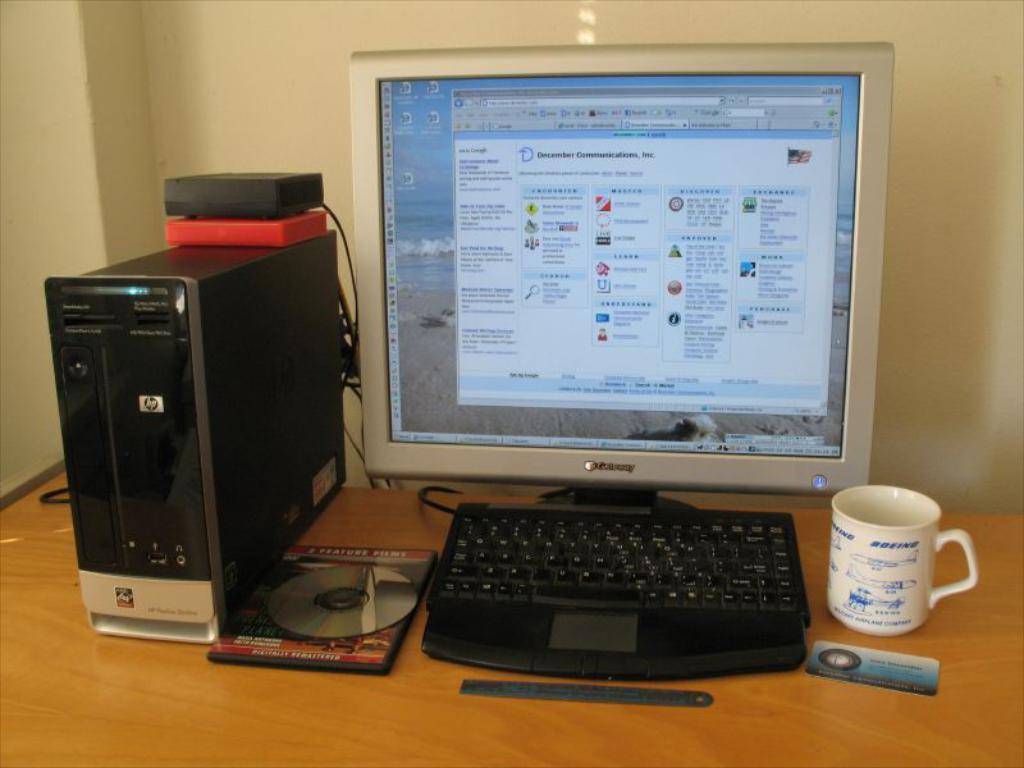What piece of furniture is present in the image? There is a table in the image. What electronic device is on the table? There is a monitor on the table. What type of container is on the table? There is a mug on the table. What is the main component of a computer system on the table? There is a CPU on the table. What device for reading CDs is on the table? There is a CD drive on the table. What sharp object is on the table? There is a blade on the table. What type of texture can be seen on the cobweb in the image? There is no cobweb present in the image. 